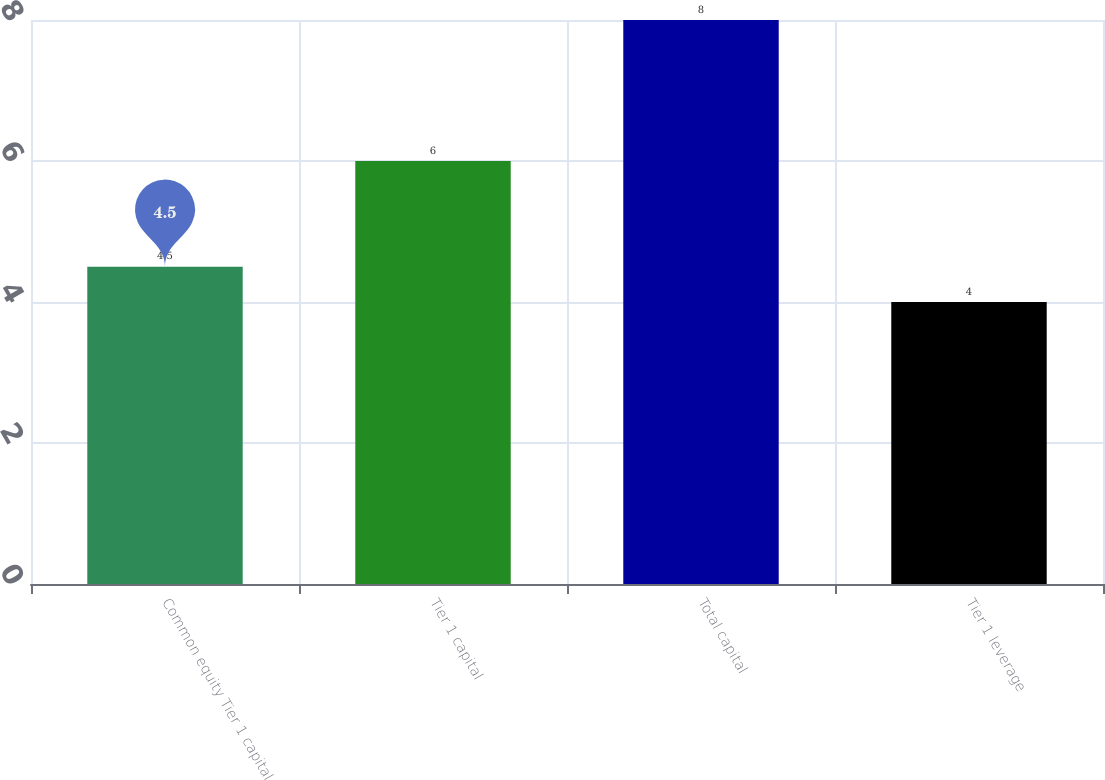Convert chart to OTSL. <chart><loc_0><loc_0><loc_500><loc_500><bar_chart><fcel>Common equity Tier 1 capital<fcel>Tier 1 capital<fcel>Total capital<fcel>Tier 1 leverage<nl><fcel>4.5<fcel>6<fcel>8<fcel>4<nl></chart> 